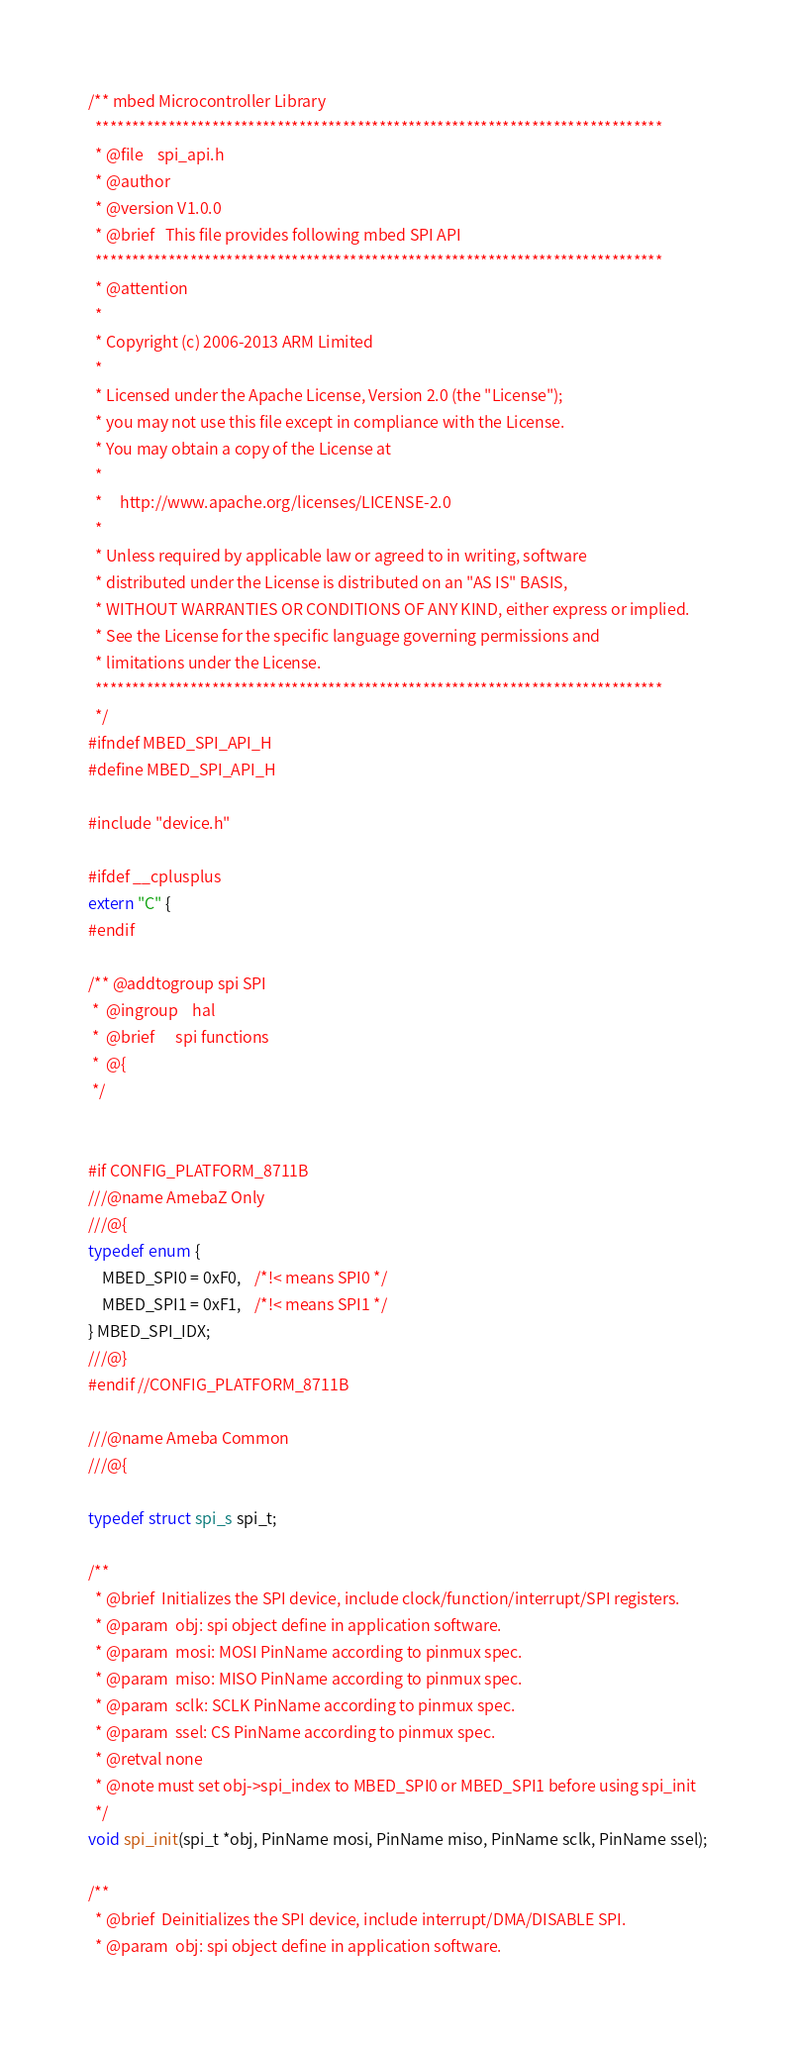<code> <loc_0><loc_0><loc_500><loc_500><_C_>/** mbed Microcontroller Library
  ******************************************************************************
  * @file    spi_api.h
  * @author 
  * @version V1.0.0
  * @brief   This file provides following mbed SPI API
  ******************************************************************************
  * @attention
  *
  * Copyright (c) 2006-2013 ARM Limited
  *
  * Licensed under the Apache License, Version 2.0 (the "License");
  * you may not use this file except in compliance with the License.
  * You may obtain a copy of the License at
  *
  *     http://www.apache.org/licenses/LICENSE-2.0
  *
  * Unless required by applicable law or agreed to in writing, software
  * distributed under the License is distributed on an "AS IS" BASIS,
  * WITHOUT WARRANTIES OR CONDITIONS OF ANY KIND, either express or implied.
  * See the License for the specific language governing permissions and
  * limitations under the License.
  ****************************************************************************** 
  */
#ifndef MBED_SPI_API_H
#define MBED_SPI_API_H

#include "device.h"

#ifdef __cplusplus
extern "C" {
#endif

/** @addtogroup spi SPI
 *  @ingroup    hal
 *  @brief      spi functions
 *  @{
 */


#if CONFIG_PLATFORM_8711B
///@name AmebaZ Only 
///@{
typedef enum {
	MBED_SPI0 = 0xF0,	/*!< means SPI0 */
	MBED_SPI1 = 0xF1,	/*!< means SPI1 */
} MBED_SPI_IDX;
///@}
#endif //CONFIG_PLATFORM_8711B

///@name Ameba Common
///@{

typedef struct spi_s spi_t;

/**
  * @brief  Initializes the SPI device, include clock/function/interrupt/SPI registers.
  * @param  obj: spi object define in application software.
  * @param  mosi: MOSI PinName according to pinmux spec.
  * @param  miso: MISO PinName according to pinmux spec.
  * @param  sclk: SCLK PinName according to pinmux spec.
  * @param  ssel: CS PinName according to pinmux spec.
  * @retval none  
  * @note must set obj->spi_index to MBED_SPI0 or MBED_SPI1 before using spi_init
  */
void spi_init(spi_t *obj, PinName mosi, PinName miso, PinName sclk, PinName ssel);

/**
  * @brief  Deinitializes the SPI device, include interrupt/DMA/DISABLE SPI.
  * @param  obj: spi object define in application software.</code> 